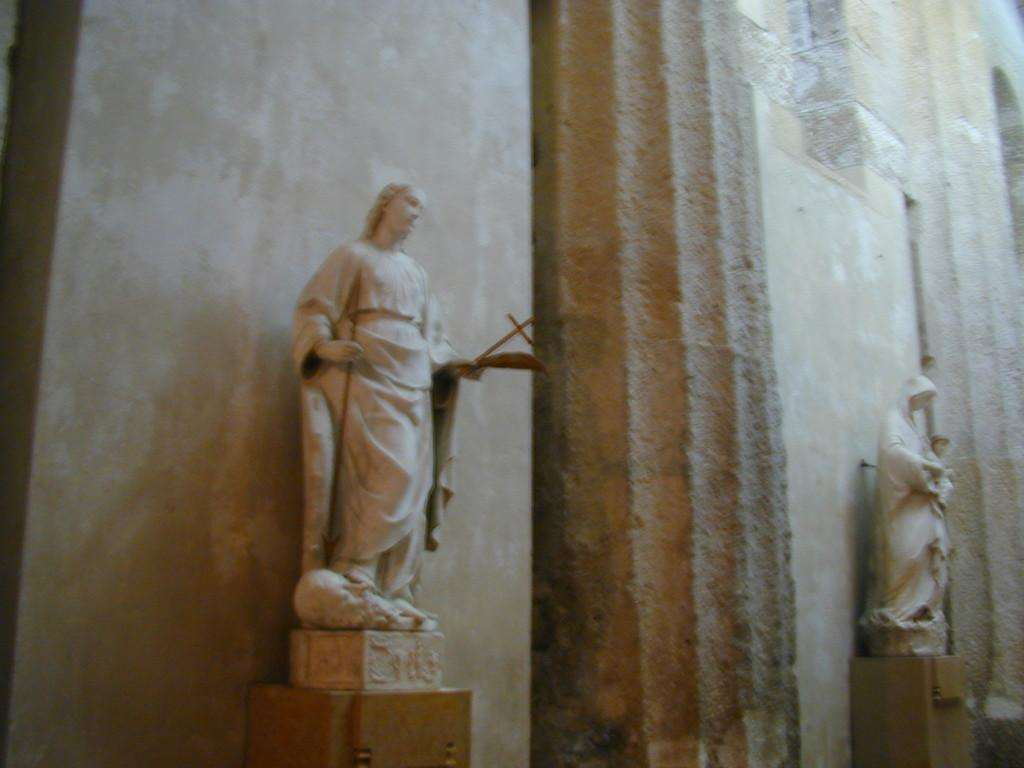What is the main subject in the image? There is a statue in the image. Where is the statue located? The statue is on a platform. What other architectural elements can be seen in the image? There is a wall and pillars in the image. What industry is represented by the statue in the image? There is no indication of any specific industry being represented by the statue in the image. 